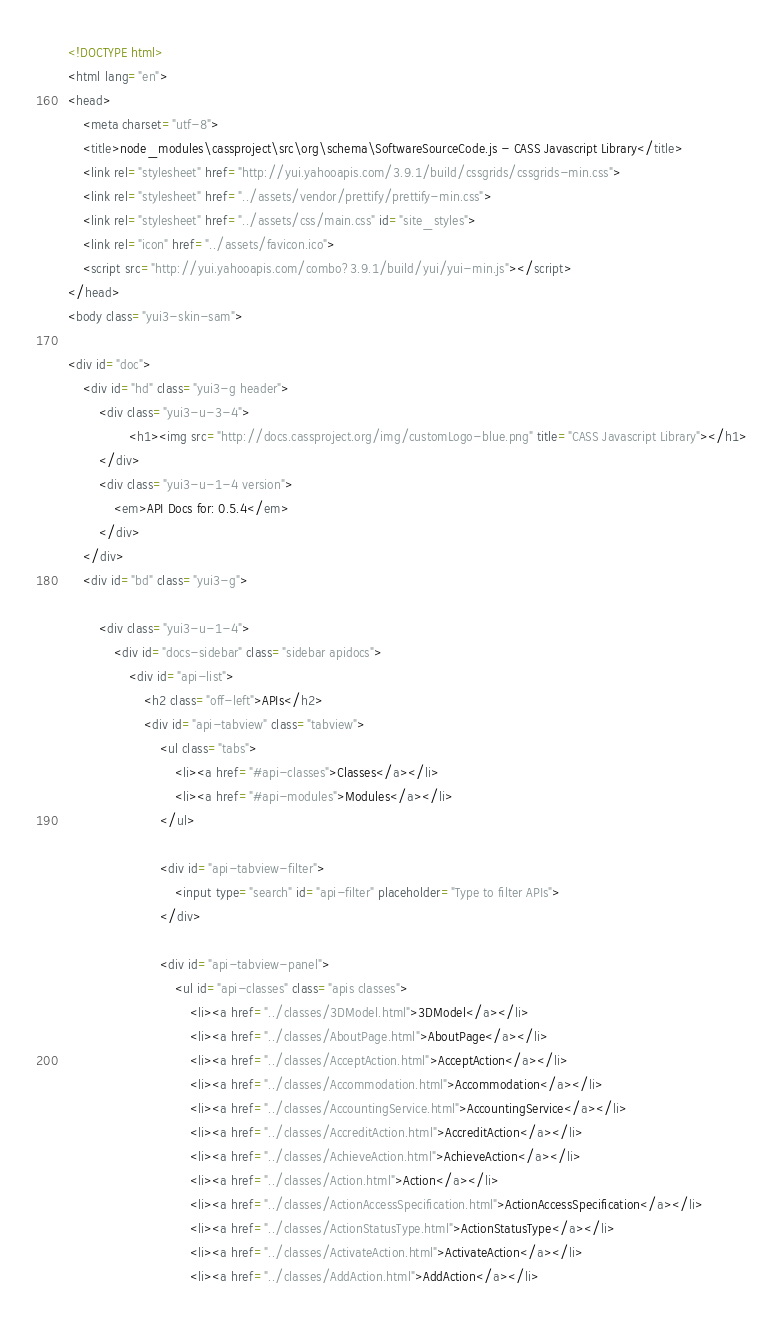Convert code to text. <code><loc_0><loc_0><loc_500><loc_500><_HTML_><!DOCTYPE html>
<html lang="en">
<head>
    <meta charset="utf-8">
    <title>node_modules\cassproject\src\org\schema\SoftwareSourceCode.js - CASS Javascript Library</title>
    <link rel="stylesheet" href="http://yui.yahooapis.com/3.9.1/build/cssgrids/cssgrids-min.css">
    <link rel="stylesheet" href="../assets/vendor/prettify/prettify-min.css">
    <link rel="stylesheet" href="../assets/css/main.css" id="site_styles">
    <link rel="icon" href="../assets/favicon.ico">
    <script src="http://yui.yahooapis.com/combo?3.9.1/build/yui/yui-min.js"></script>
</head>
<body class="yui3-skin-sam">

<div id="doc">
    <div id="hd" class="yui3-g header">
        <div class="yui3-u-3-4">
                <h1><img src="http://docs.cassproject.org/img/customLogo-blue.png" title="CASS Javascript Library"></h1>
        </div>
        <div class="yui3-u-1-4 version">
            <em>API Docs for: 0.5.4</em>
        </div>
    </div>
    <div id="bd" class="yui3-g">

        <div class="yui3-u-1-4">
            <div id="docs-sidebar" class="sidebar apidocs">
                <div id="api-list">
                    <h2 class="off-left">APIs</h2>
                    <div id="api-tabview" class="tabview">
                        <ul class="tabs">
                            <li><a href="#api-classes">Classes</a></li>
                            <li><a href="#api-modules">Modules</a></li>
                        </ul>
                
                        <div id="api-tabview-filter">
                            <input type="search" id="api-filter" placeholder="Type to filter APIs">
                        </div>
                
                        <div id="api-tabview-panel">
                            <ul id="api-classes" class="apis classes">
                                <li><a href="../classes/3DModel.html">3DModel</a></li>
                                <li><a href="../classes/AboutPage.html">AboutPage</a></li>
                                <li><a href="../classes/AcceptAction.html">AcceptAction</a></li>
                                <li><a href="../classes/Accommodation.html">Accommodation</a></li>
                                <li><a href="../classes/AccountingService.html">AccountingService</a></li>
                                <li><a href="../classes/AccreditAction.html">AccreditAction</a></li>
                                <li><a href="../classes/AchieveAction.html">AchieveAction</a></li>
                                <li><a href="../classes/Action.html">Action</a></li>
                                <li><a href="../classes/ActionAccessSpecification.html">ActionAccessSpecification</a></li>
                                <li><a href="../classes/ActionStatusType.html">ActionStatusType</a></li>
                                <li><a href="../classes/ActivateAction.html">ActivateAction</a></li>
                                <li><a href="../classes/AddAction.html">AddAction</a></li></code> 